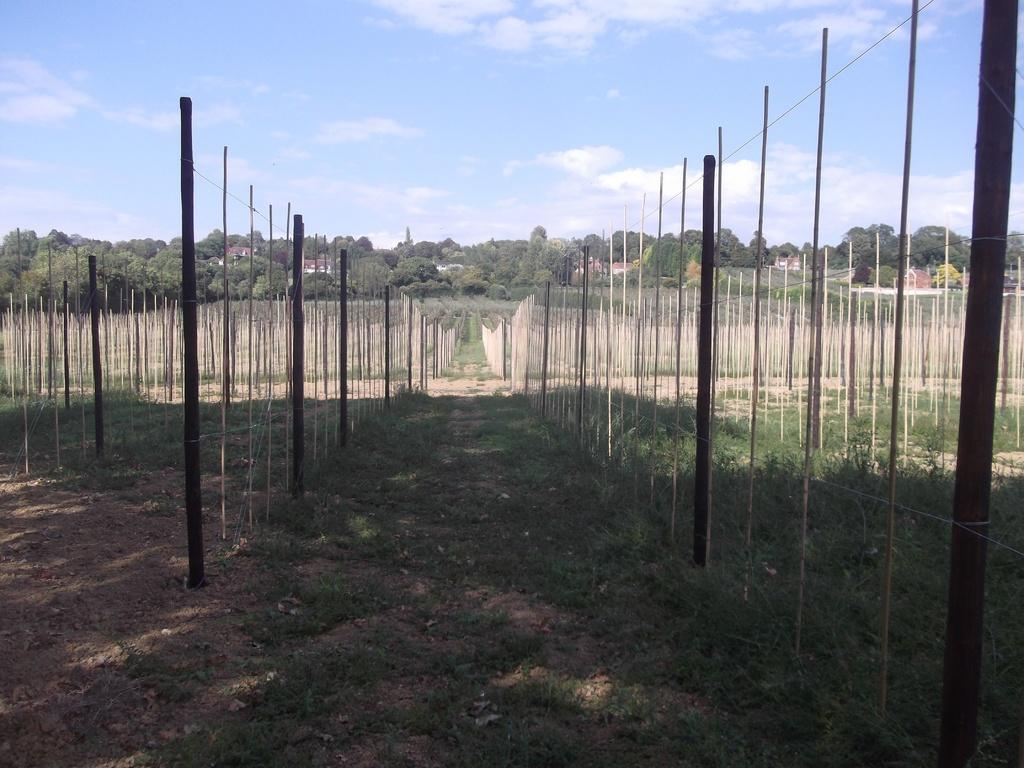What can be seen in the image that resembles a series of vertical structures? There is a group of poles in the image. What other natural elements are present in the image? There is a group of trees in the image. What type of man-made structures can be seen in the image? There are buildings in the image. What is visible in the background of the image? The sky is visible in the background of the image. What is the condition of the sky in the image? The sky is cloudy in the image. Can you see a duck wearing a crown in the image? There is no duck or crown present in the image. What type of jam is being spread on the buildings in the image? There is no jam present in the image, and the buildings are not being spread with any substance. 